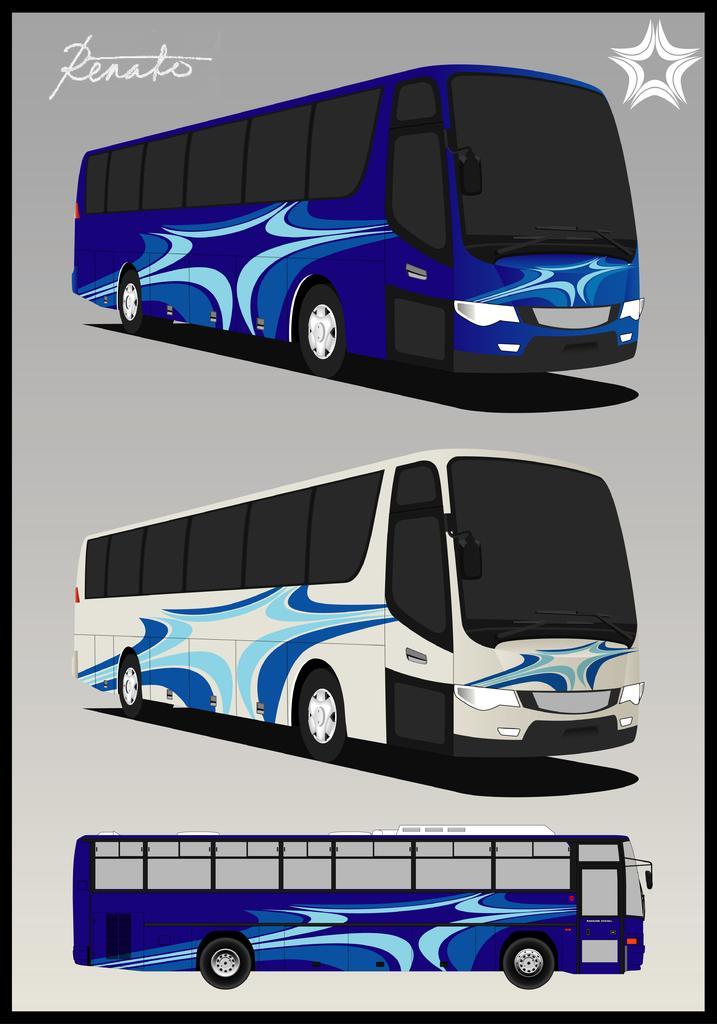How would you summarize this image in a sentence or two? In this image we can see the depictions of three persons. We can also see the text and the image has borders. 